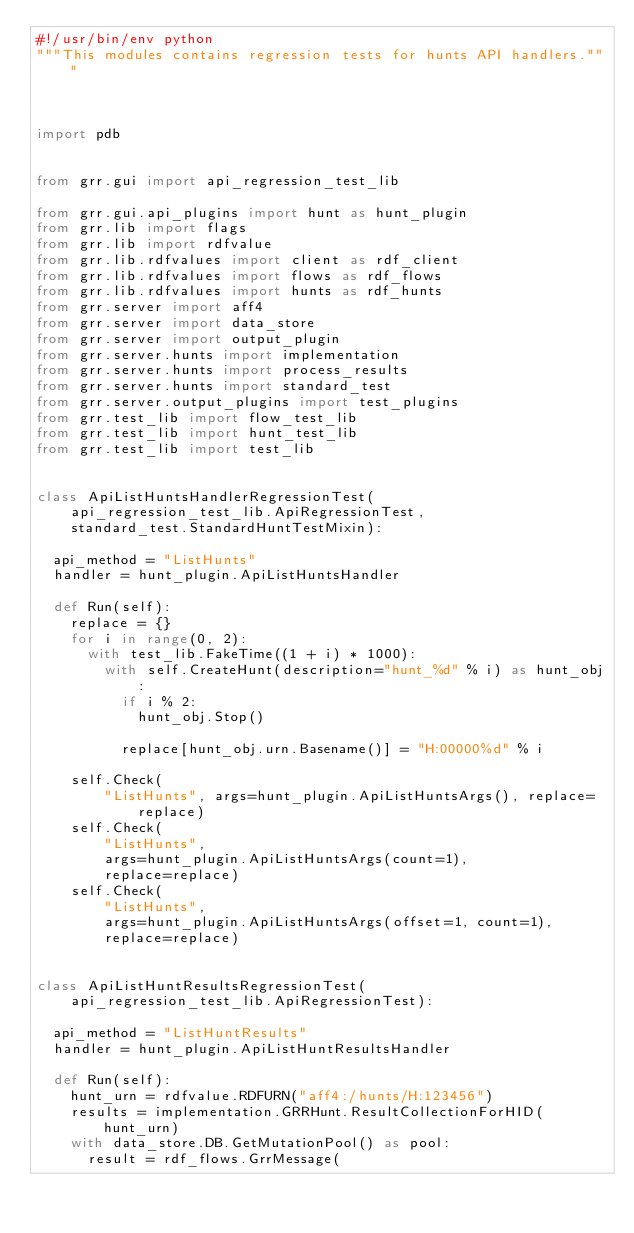Convert code to text. <code><loc_0><loc_0><loc_500><loc_500><_Python_>#!/usr/bin/env python
"""This modules contains regression tests for hunts API handlers."""



import pdb


from grr.gui import api_regression_test_lib

from grr.gui.api_plugins import hunt as hunt_plugin
from grr.lib import flags
from grr.lib import rdfvalue
from grr.lib.rdfvalues import client as rdf_client
from grr.lib.rdfvalues import flows as rdf_flows
from grr.lib.rdfvalues import hunts as rdf_hunts
from grr.server import aff4
from grr.server import data_store
from grr.server import output_plugin
from grr.server.hunts import implementation
from grr.server.hunts import process_results
from grr.server.hunts import standard_test
from grr.server.output_plugins import test_plugins
from grr.test_lib import flow_test_lib
from grr.test_lib import hunt_test_lib
from grr.test_lib import test_lib


class ApiListHuntsHandlerRegressionTest(
    api_regression_test_lib.ApiRegressionTest,
    standard_test.StandardHuntTestMixin):

  api_method = "ListHunts"
  handler = hunt_plugin.ApiListHuntsHandler

  def Run(self):
    replace = {}
    for i in range(0, 2):
      with test_lib.FakeTime((1 + i) * 1000):
        with self.CreateHunt(description="hunt_%d" % i) as hunt_obj:
          if i % 2:
            hunt_obj.Stop()

          replace[hunt_obj.urn.Basename()] = "H:00000%d" % i

    self.Check(
        "ListHunts", args=hunt_plugin.ApiListHuntsArgs(), replace=replace)
    self.Check(
        "ListHunts",
        args=hunt_plugin.ApiListHuntsArgs(count=1),
        replace=replace)
    self.Check(
        "ListHunts",
        args=hunt_plugin.ApiListHuntsArgs(offset=1, count=1),
        replace=replace)


class ApiListHuntResultsRegressionTest(
    api_regression_test_lib.ApiRegressionTest):

  api_method = "ListHuntResults"
  handler = hunt_plugin.ApiListHuntResultsHandler

  def Run(self):
    hunt_urn = rdfvalue.RDFURN("aff4:/hunts/H:123456")
    results = implementation.GRRHunt.ResultCollectionForHID(hunt_urn)
    with data_store.DB.GetMutationPool() as pool:
      result = rdf_flows.GrrMessage(</code> 